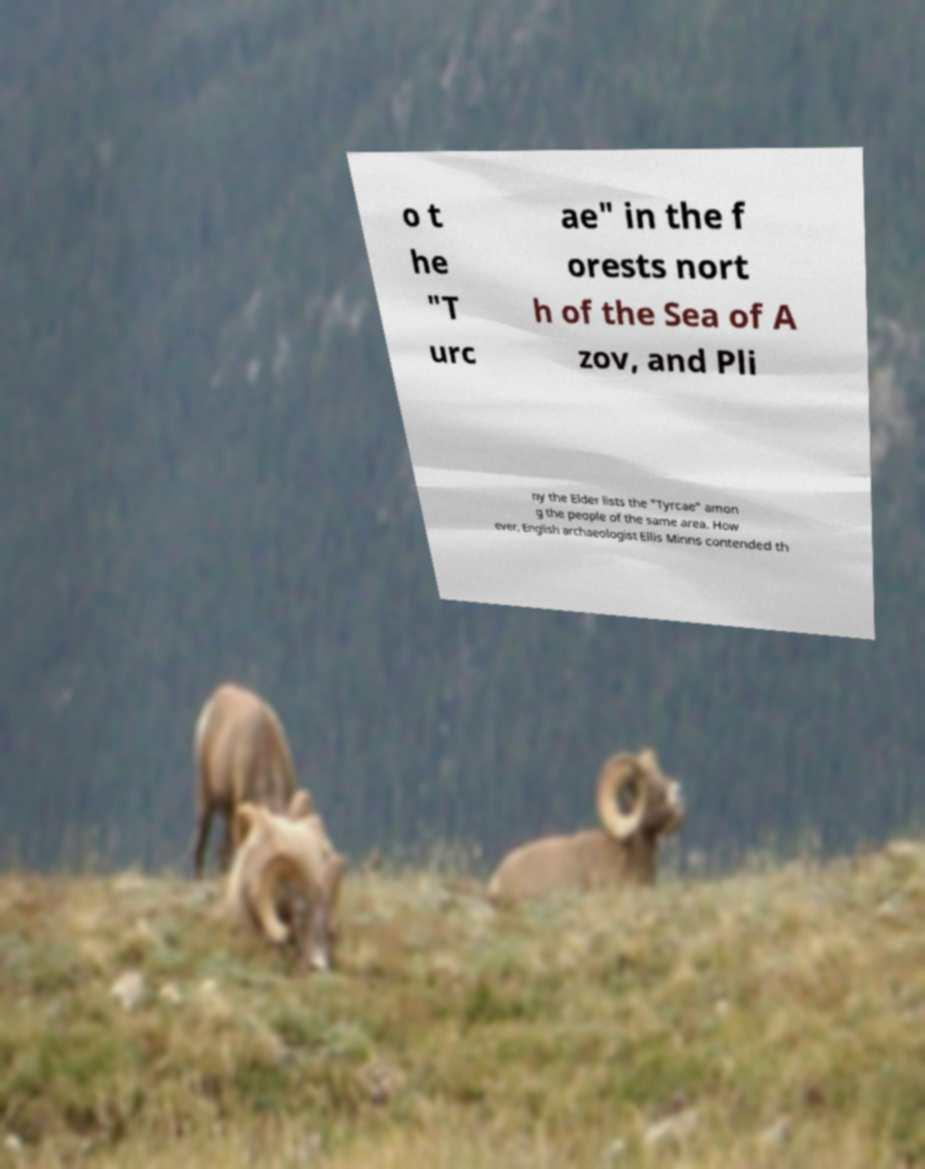Please read and relay the text visible in this image. What does it say? o t he "T urc ae" in the f orests nort h of the Sea of A zov, and Pli ny the Elder lists the "Tyrcae" amon g the people of the same area. How ever, English archaeologist Ellis Minns contended th 